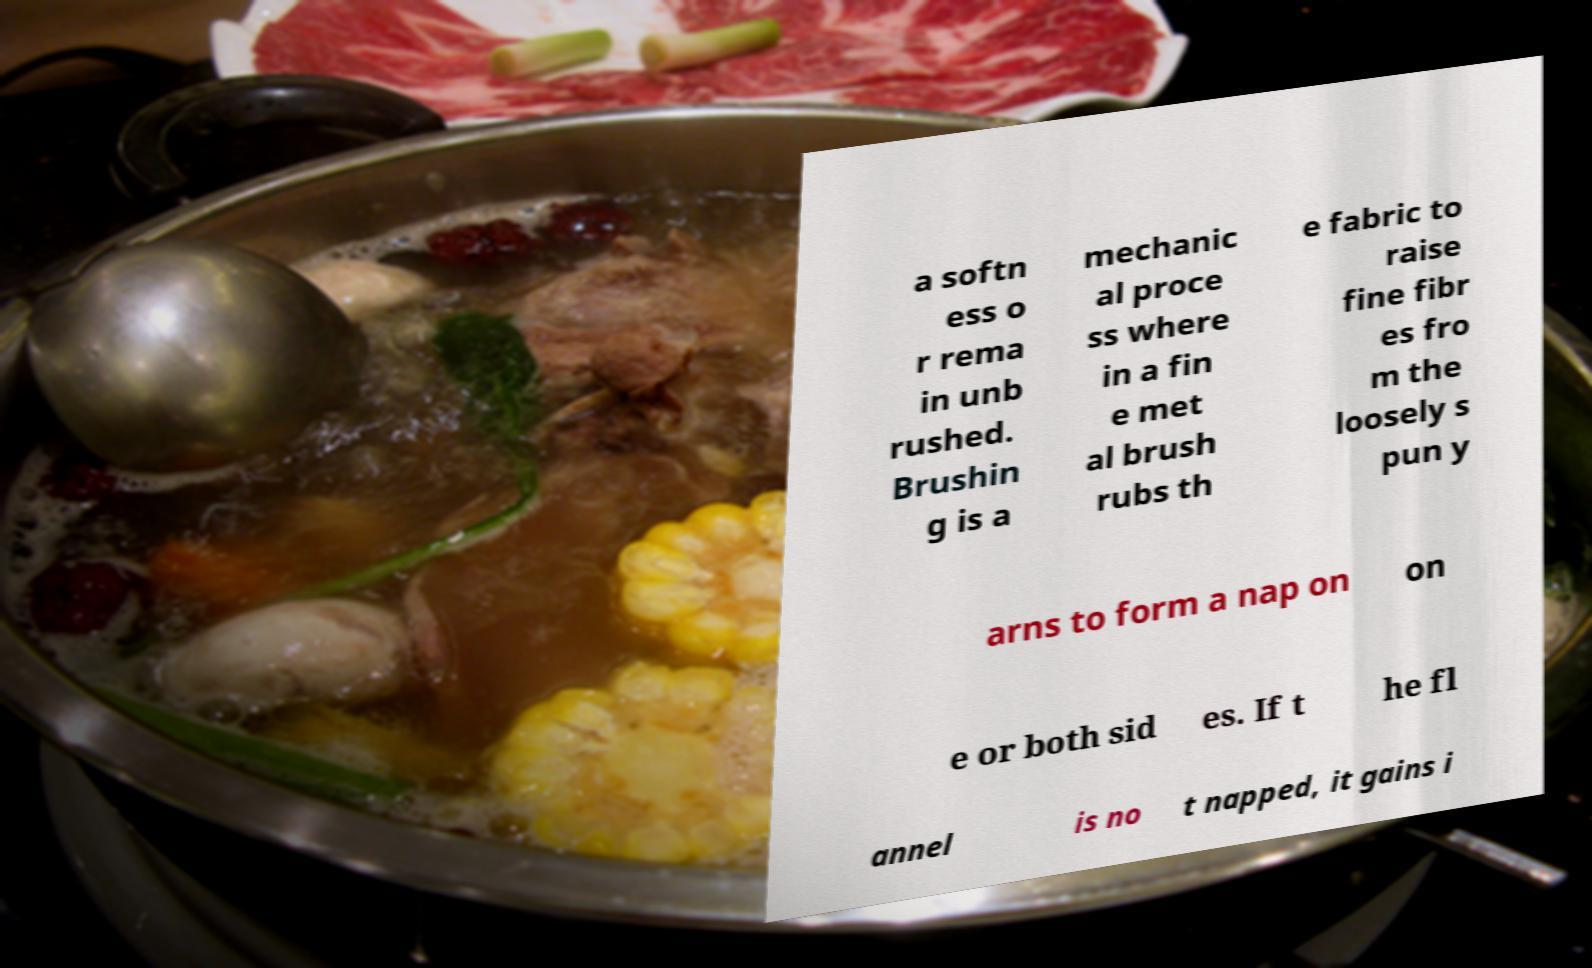Please read and relay the text visible in this image. What does it say? a softn ess o r rema in unb rushed. Brushin g is a mechanic al proce ss where in a fin e met al brush rubs th e fabric to raise fine fibr es fro m the loosely s pun y arns to form a nap on on e or both sid es. If t he fl annel is no t napped, it gains i 